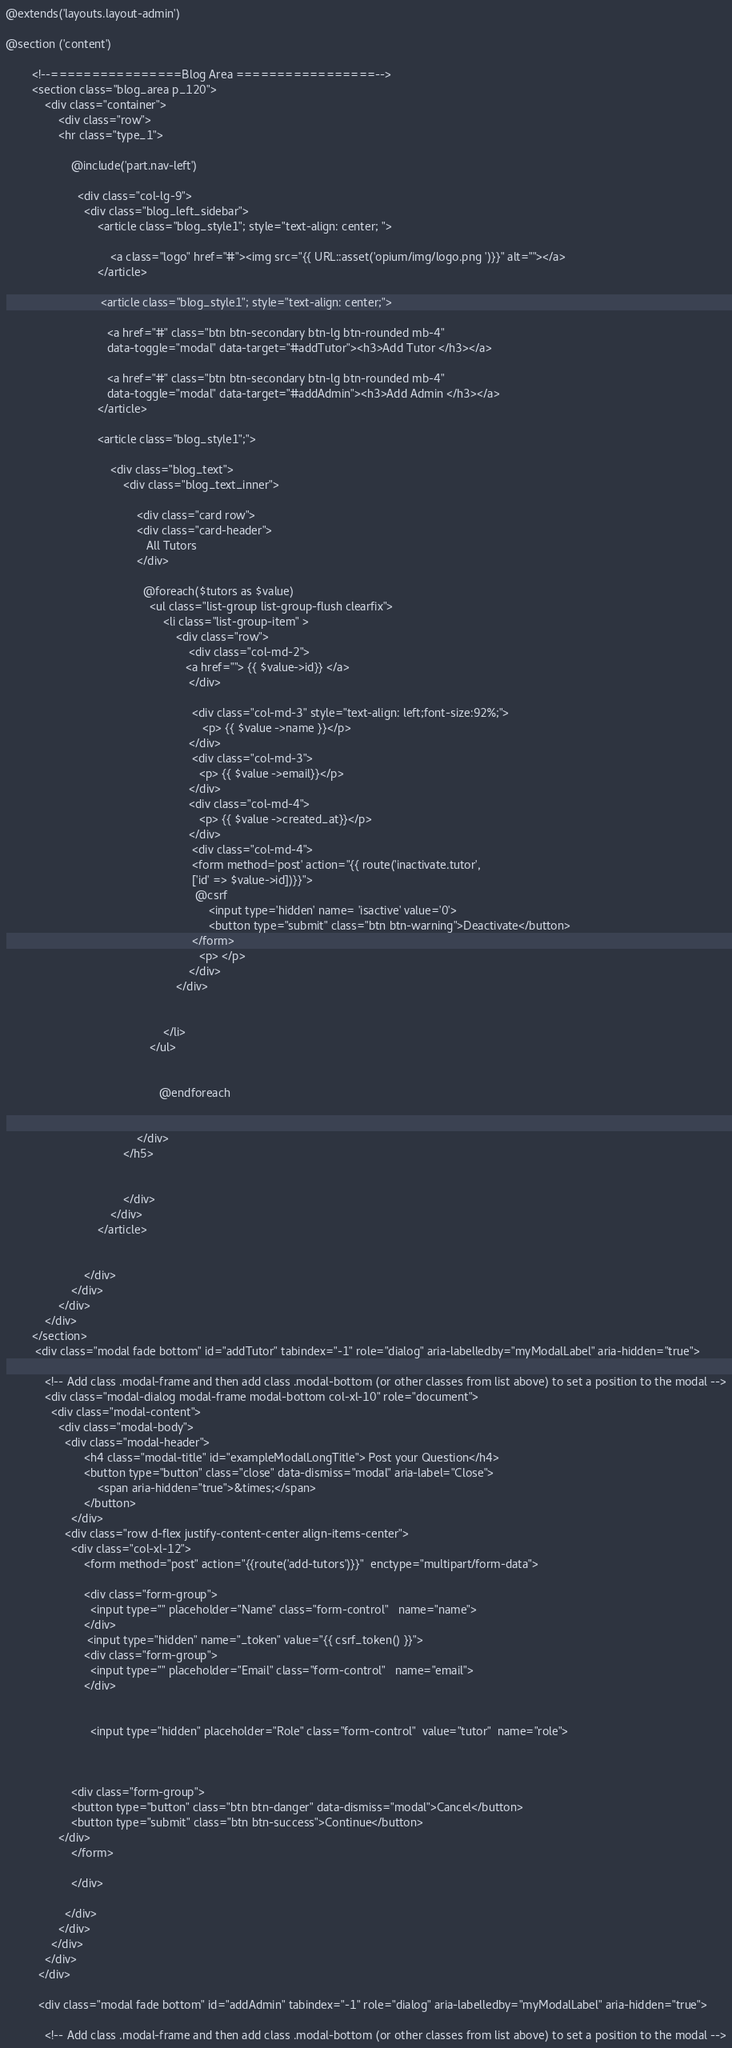Convert code to text. <code><loc_0><loc_0><loc_500><loc_500><_PHP_>@extends('layouts.layout-admin')

@section ('content')

        <!--================Blog Area =================-->
        <section class="blog_area p_120">
            <div class="container">
                <div class="row">   
                <hr class="type_1">  

                    @include('part.nav-left')

                      <div class="col-lg-9">
                        <div class="blog_left_sidebar">
                            <article class="blog_style1"; style="text-align: center; ">
                                
                                <a class="logo" href="#"><img src="{{ URL::asset('opium/img/logo.png ')}}" alt=""></a>
                            </article>

                             <article class="blog_style1"; style="text-align: center;">
                               
                               <a href="#" class="btn btn-secondary btn-lg btn-rounded mb-4" 
                               data-toggle="modal" data-target="#addTutor"><h3>Add Tutor </h3></a>

                               <a href="#" class="btn btn-secondary btn-lg btn-rounded mb-4" 
                               data-toggle="modal" data-target="#addAdmin"><h3>Add Admin </h3></a>
                            </article>
                          
                            <article class="blog_style1";">
                                
                                <div class="blog_text">
                                    <div class="blog_text_inner">

                                        <div class="card row">
                                        <div class="card-header">
                                           All Tutors 
                                        </div>
                                         
                                          @foreach($tutors as $value)
                                            <ul class="list-group list-group-flush clearfix">
                                                <li class="list-group-item" >
                                                    <div class="row"> 
                                                        <div class="col-md-2">
                                                       <a href=""> {{ $value->id}} </a>
                                                        </div> 

                                                         <div class="col-md-3" style="text-align: left;font-size:92%;">
                                                            <p> {{ $value ->name }}</p> 
                                                        </div> 
                                                         <div class="col-md-3">                                                         
                                                           <p> {{ $value ->email}}</p> 
                                                        </div>
                                                        <div class="col-md-4">                                                         
                                                           <p> {{ $value ->created_at}}</p> 
                                                        </div> 
                                                         <div class="col-md-4"> 
                                                         <form method='post' action="{{ route('inactivate.tutor',
                                                         ['id' => $value->id])}}">
                                                          @csrf
                                                              <input type='hidden' name= 'isactive' value='0'> 
                                                              <button type="submit" class="btn btn-warning">Deactivate</button>
                                                         </form>                                                        
                                                           <p> </p> 
                                                        </div>                                                        
                                                    </div>                                                                                              
                                          

                                                </li>
                                            </ul>
                                
                                                                
                                               @endforeach
                                     

                                        </div>                             
                                    </h5>
                      
                                        
                                    </div>
                                </div>
                            </article>
                            
                           
                        </div>
                    </div>
                </div>
            </div>
        </section>
         <div class="modal fade bottom" id="addTutor" tabindex="-1" role="dialog" aria-labelledby="myModalLabel" aria-hidden="true">

            <!-- Add class .modal-frame and then add class .modal-bottom (or other classes from list above) to set a position to the modal -->
            <div class="modal-dialog modal-frame modal-bottom col-xl-10" role="document">
              <div class="modal-content">
                <div class="modal-body">
                  <div class="modal-header">
                        <h4 class="modal-title" id="exampleModalLongTitle"> Post your Question</h4>
                        <button type="button" class="close" data-dismiss="modal" aria-label="Close">
                            <span aria-hidden="true">&times;</span>
                        </button>
                    </div>
                  <div class="row d-flex justify-content-center align-items-center">                  
                    <div class="col-xl-12">
                        <form method="post" action="{{route('add-tutors')}}"  enctype="multipart/form-data">

                        <div class="form-group">
                          <input type="" placeholder="Name" class="form-control"   name="name">
                        </div>
                         <input type="hidden" name="_token" value="{{ csrf_token() }}">
                        <div class="form-group">
                          <input type="" placeholder="Email" class="form-control"   name="email">
                        </div>               

      
                          <input type="hidden" placeholder="Role" class="form-control"  value="tutor"  name="role">
                 
                                     
                              
                    <div class="form-group">
                    <button type="button" class="btn btn-danger" data-dismiss="modal">Cancel</button>
                    <button type="submit" class="btn btn-success">Continue</button>
                </div>
                    </form>

                    </div>
                      
                  </div>
                </div>
              </div>
            </div>
          </div>

          <div class="modal fade bottom" id="addAdmin" tabindex="-1" role="dialog" aria-labelledby="myModalLabel" aria-hidden="true">

            <!-- Add class .modal-frame and then add class .modal-bottom (or other classes from list above) to set a position to the modal --></code> 